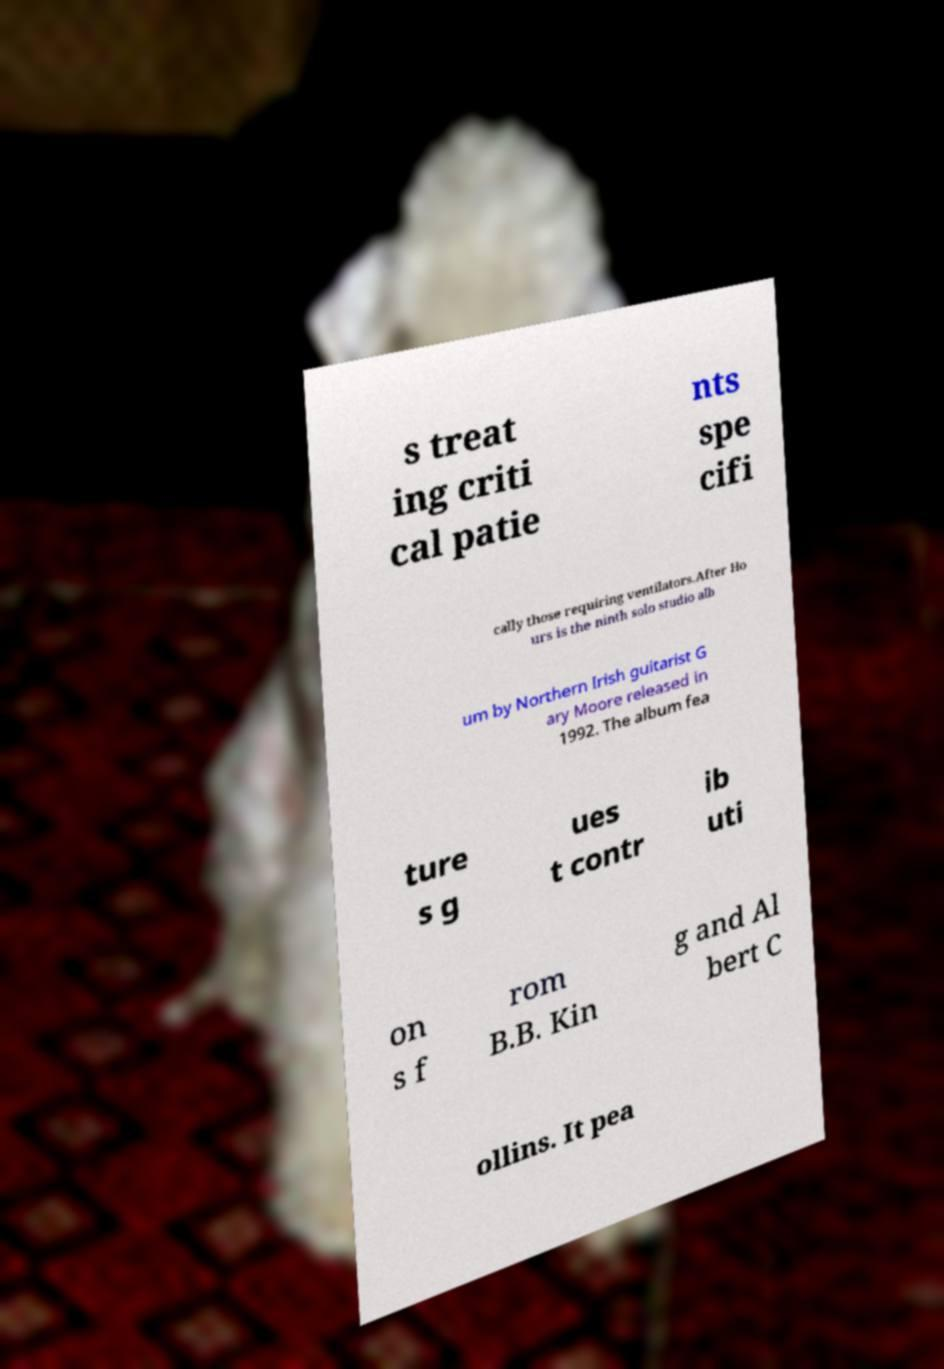Please read and relay the text visible in this image. What does it say? s treat ing criti cal patie nts spe cifi cally those requiring ventilators.After Ho urs is the ninth solo studio alb um by Northern Irish guitarist G ary Moore released in 1992. The album fea ture s g ues t contr ib uti on s f rom B.B. Kin g and Al bert C ollins. It pea 